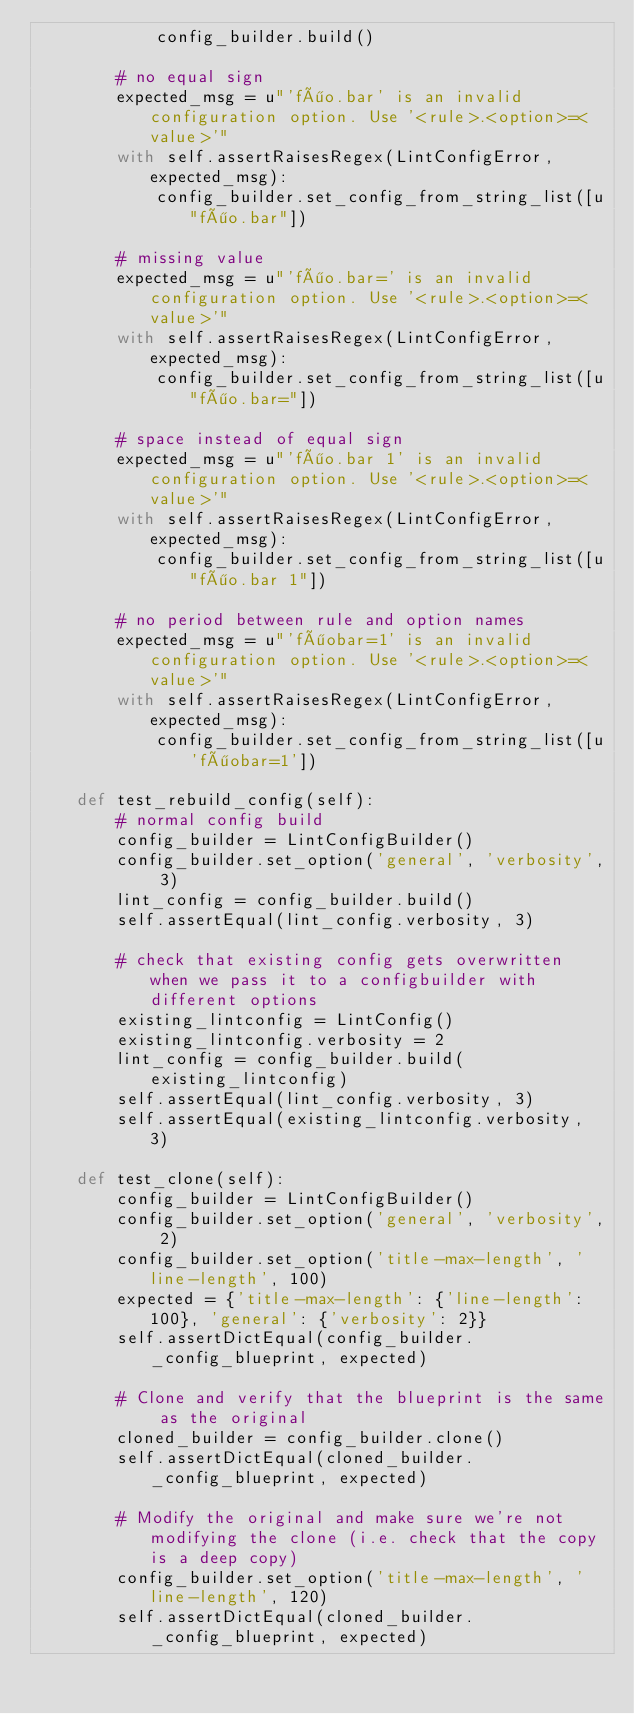<code> <loc_0><loc_0><loc_500><loc_500><_Python_>            config_builder.build()

        # no equal sign
        expected_msg = u"'föo.bar' is an invalid configuration option. Use '<rule>.<option>=<value>'"
        with self.assertRaisesRegex(LintConfigError, expected_msg):
            config_builder.set_config_from_string_list([u"föo.bar"])

        # missing value
        expected_msg = u"'föo.bar=' is an invalid configuration option. Use '<rule>.<option>=<value>'"
        with self.assertRaisesRegex(LintConfigError, expected_msg):
            config_builder.set_config_from_string_list([u"föo.bar="])

        # space instead of equal sign
        expected_msg = u"'föo.bar 1' is an invalid configuration option. Use '<rule>.<option>=<value>'"
        with self.assertRaisesRegex(LintConfigError, expected_msg):
            config_builder.set_config_from_string_list([u"föo.bar 1"])

        # no period between rule and option names
        expected_msg = u"'föobar=1' is an invalid configuration option. Use '<rule>.<option>=<value>'"
        with self.assertRaisesRegex(LintConfigError, expected_msg):
            config_builder.set_config_from_string_list([u'föobar=1'])

    def test_rebuild_config(self):
        # normal config build
        config_builder = LintConfigBuilder()
        config_builder.set_option('general', 'verbosity', 3)
        lint_config = config_builder.build()
        self.assertEqual(lint_config.verbosity, 3)

        # check that existing config gets overwritten when we pass it to a configbuilder with different options
        existing_lintconfig = LintConfig()
        existing_lintconfig.verbosity = 2
        lint_config = config_builder.build(existing_lintconfig)
        self.assertEqual(lint_config.verbosity, 3)
        self.assertEqual(existing_lintconfig.verbosity, 3)

    def test_clone(self):
        config_builder = LintConfigBuilder()
        config_builder.set_option('general', 'verbosity', 2)
        config_builder.set_option('title-max-length', 'line-length', 100)
        expected = {'title-max-length': {'line-length': 100}, 'general': {'verbosity': 2}}
        self.assertDictEqual(config_builder._config_blueprint, expected)

        # Clone and verify that the blueprint is the same as the original
        cloned_builder = config_builder.clone()
        self.assertDictEqual(cloned_builder._config_blueprint, expected)

        # Modify the original and make sure we're not modifying the clone (i.e. check that the copy is a deep copy)
        config_builder.set_option('title-max-length', 'line-length', 120)
        self.assertDictEqual(cloned_builder._config_blueprint, expected)
</code> 